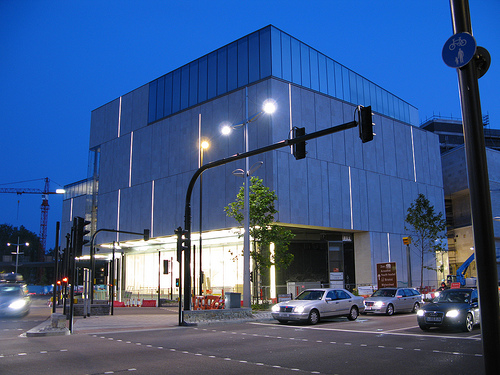Is this photo taken during the day or night? The photo seems to capture the transition between evening and night, often referred to as dusk, as evidenced by the artificial lighting and the remaining natural light in the sky. 